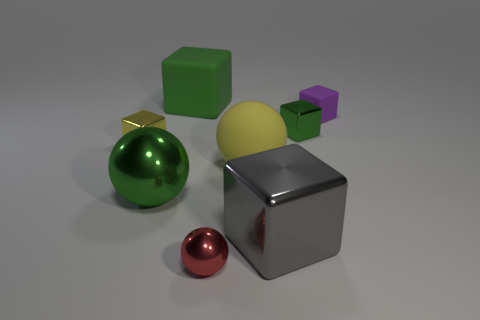How many green cubes must be subtracted to get 1 green cubes? 1 Subtract all large metal cubes. How many cubes are left? 4 Subtract all spheres. How many objects are left? 5 Subtract 1 balls. How many balls are left? 2 Subtract all yellow balls. Subtract all blue cylinders. How many balls are left? 2 Subtract all green blocks. How many red spheres are left? 1 Subtract all tiny purple metallic blocks. Subtract all large rubber cubes. How many objects are left? 7 Add 2 tiny purple rubber objects. How many tiny purple rubber objects are left? 3 Add 3 gray objects. How many gray objects exist? 4 Add 1 small cubes. How many objects exist? 9 